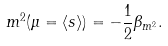<formula> <loc_0><loc_0><loc_500><loc_500>m ^ { 2 } ( \mu = \langle s \rangle ) = - \frac { 1 } { 2 } \beta _ { m ^ { 2 } } .</formula> 